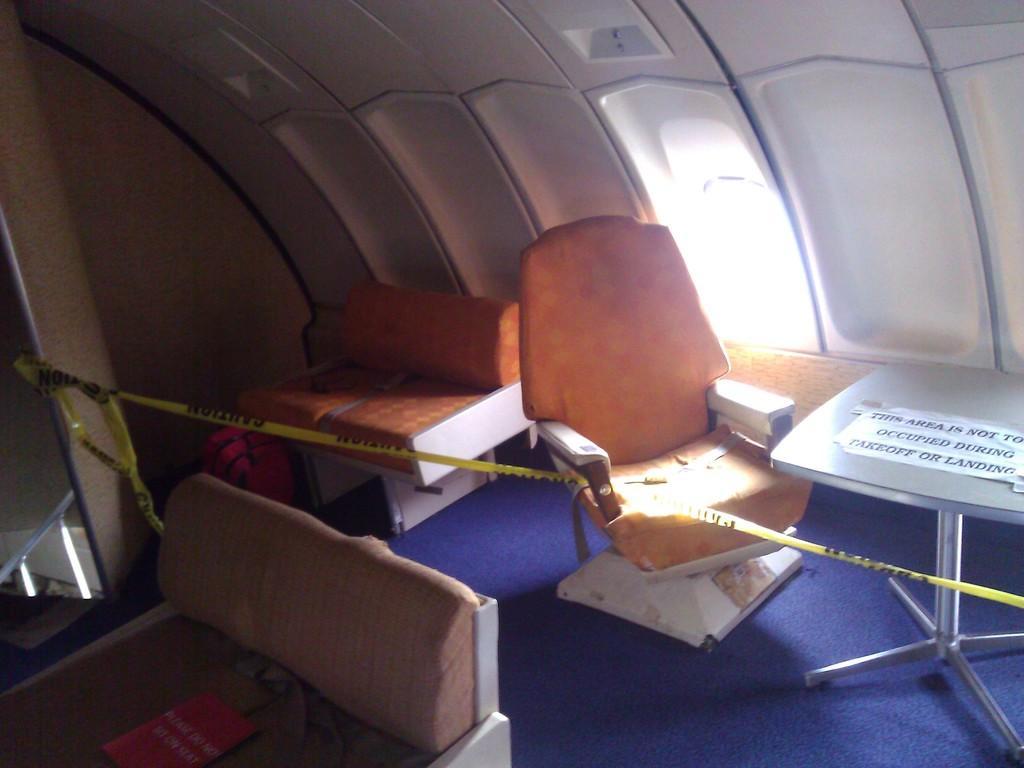Could you give a brief overview of what you see in this image? The image is taken in the flight. In the image there are seats. On the right there is a table and there is a sticker placed on the table. In the background there is a bag and a window. 